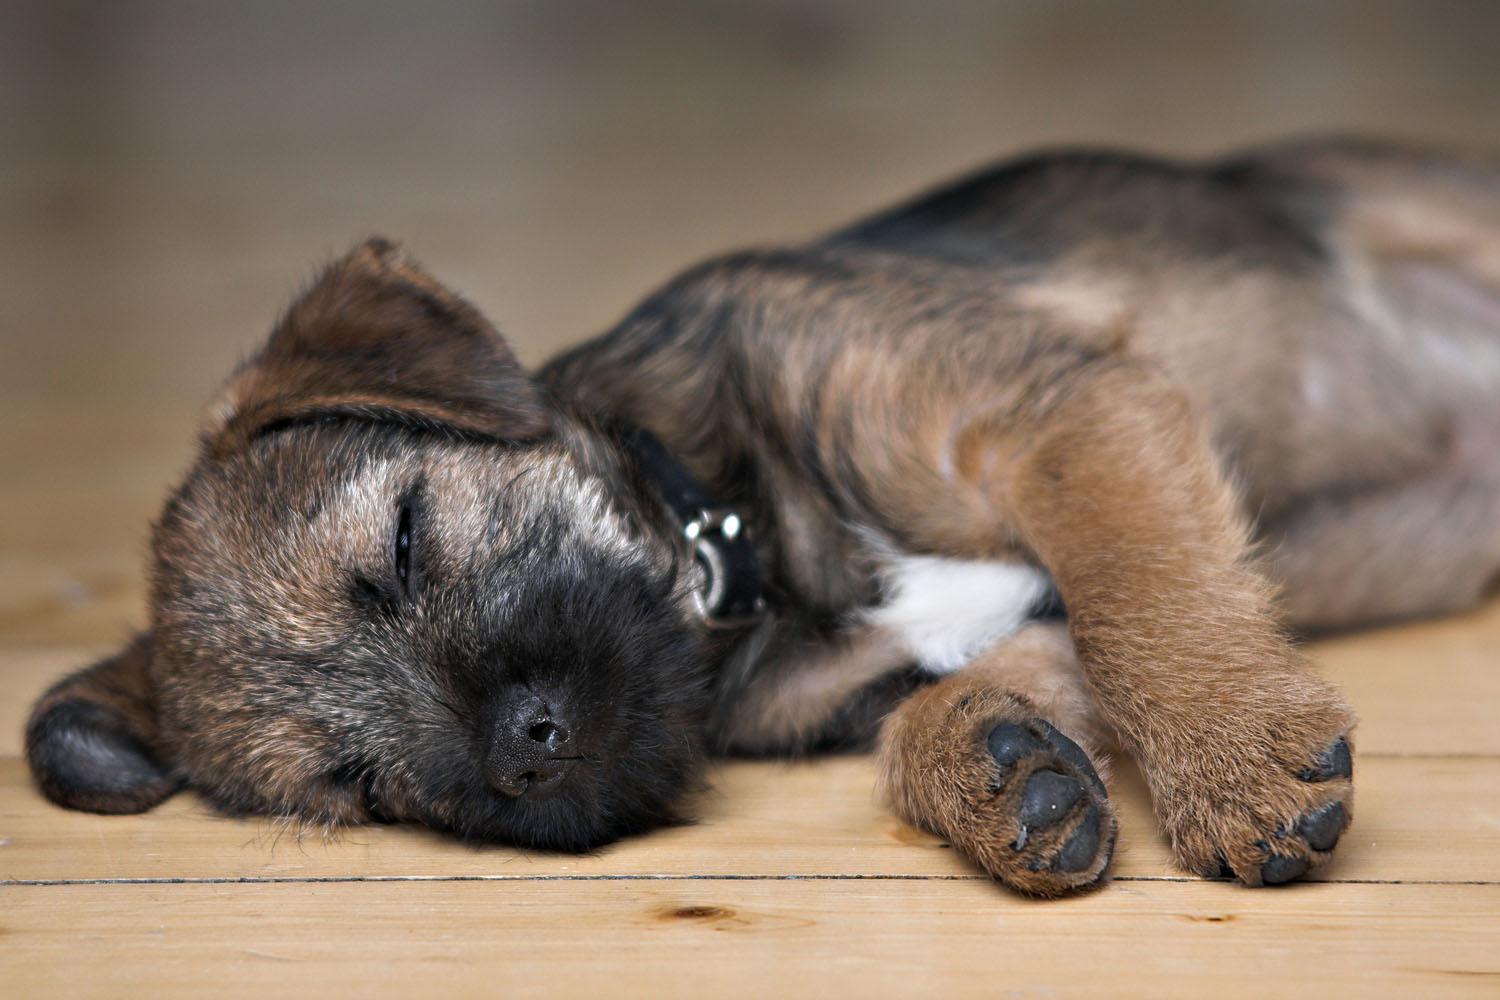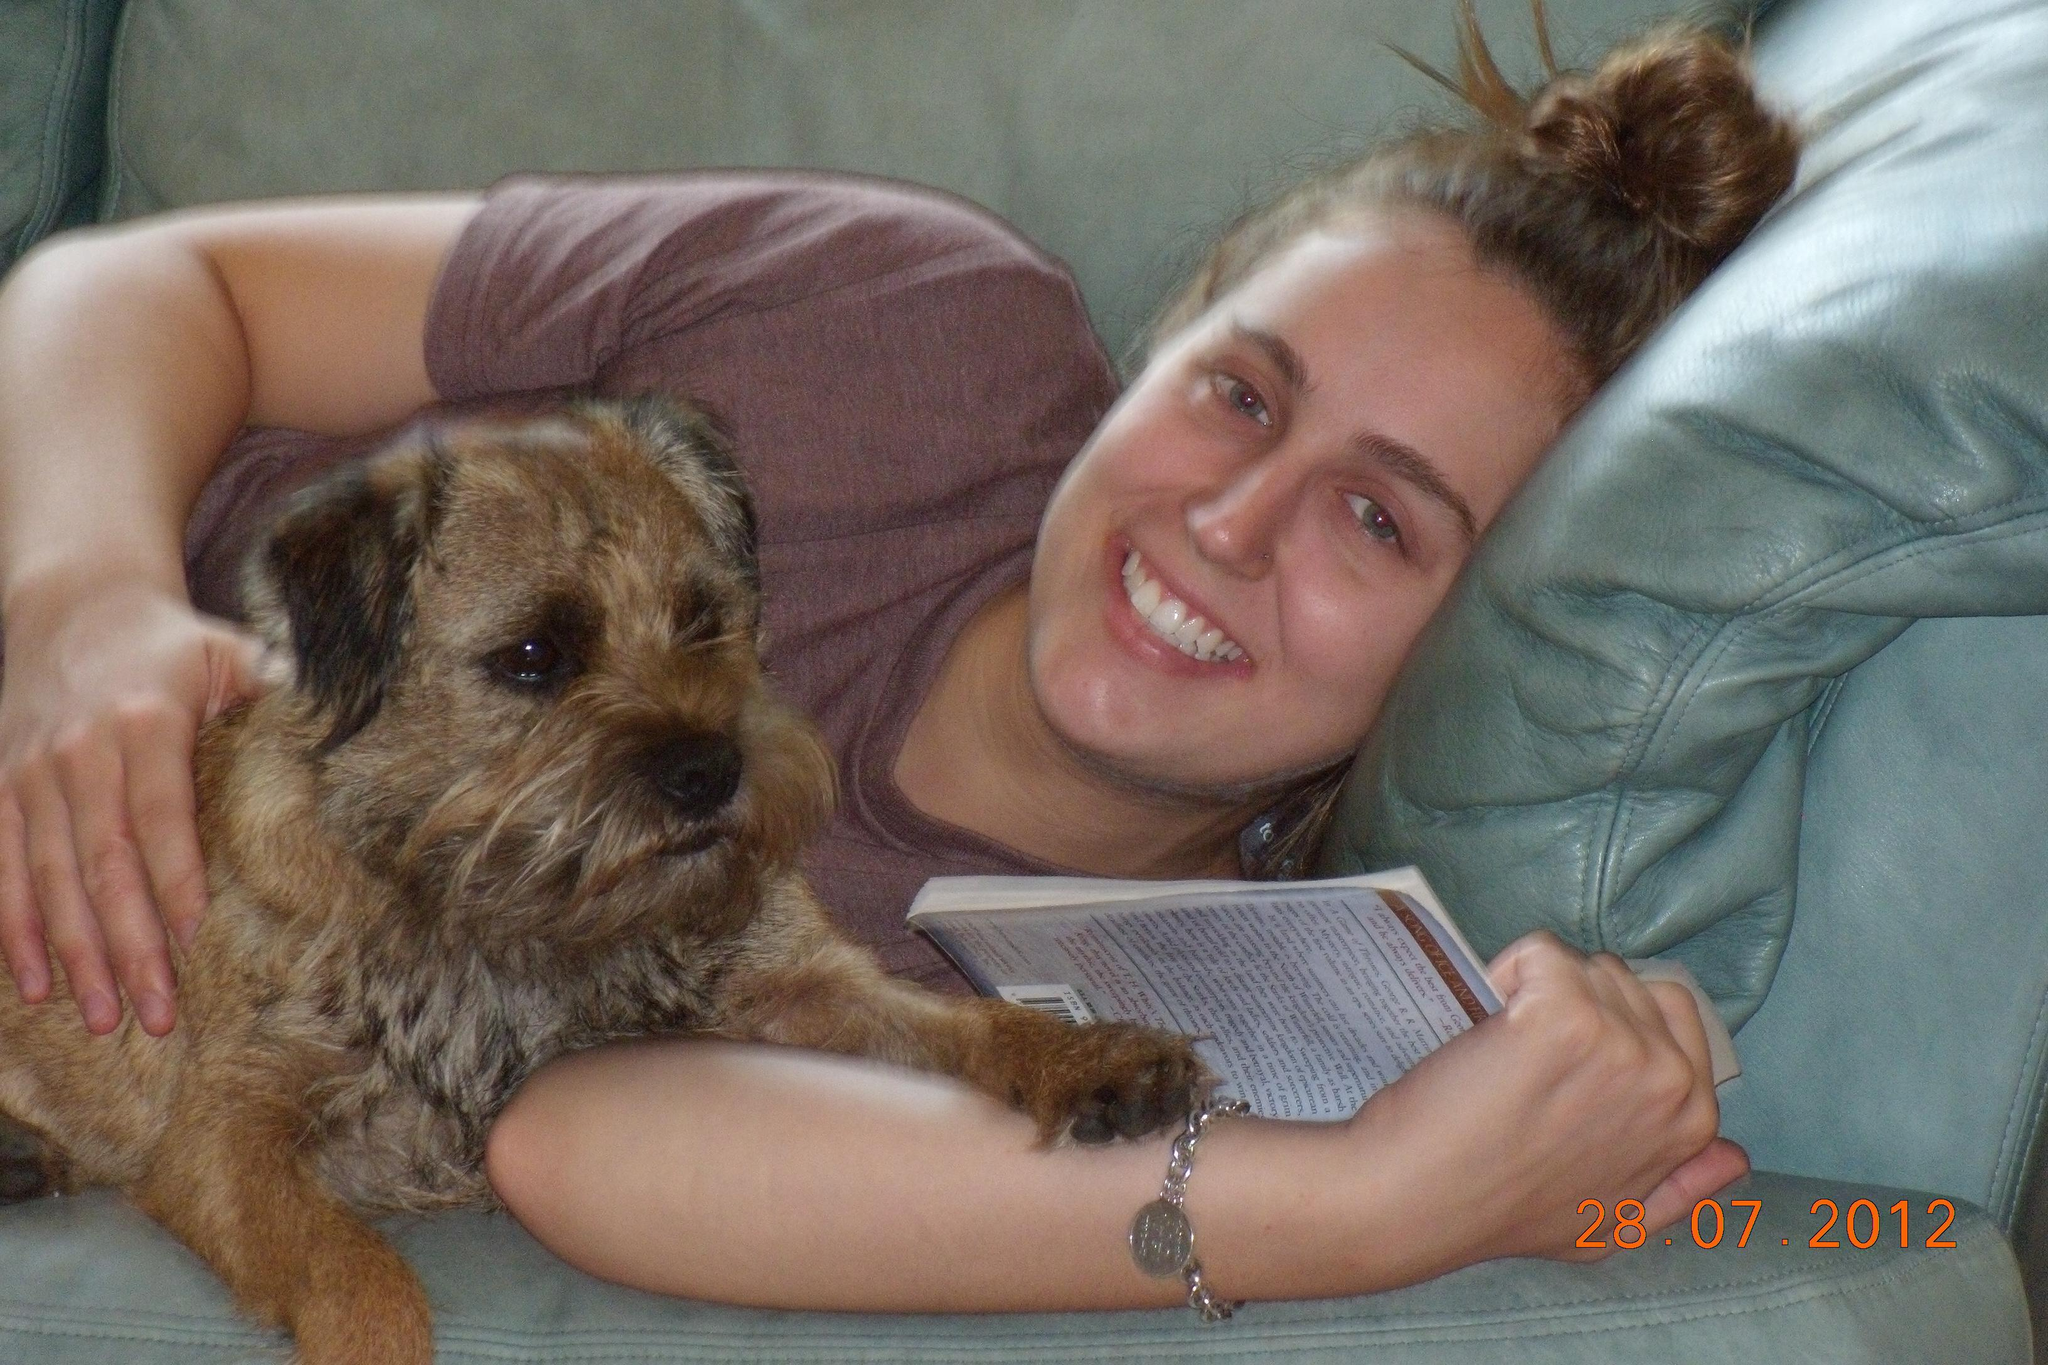The first image is the image on the left, the second image is the image on the right. Given the left and right images, does the statement "There are no more than two dogs." hold true? Answer yes or no. Yes. The first image is the image on the left, the second image is the image on the right. Analyze the images presented: Is the assertion "There are three dogs sleeping" valid? Answer yes or no. No. 